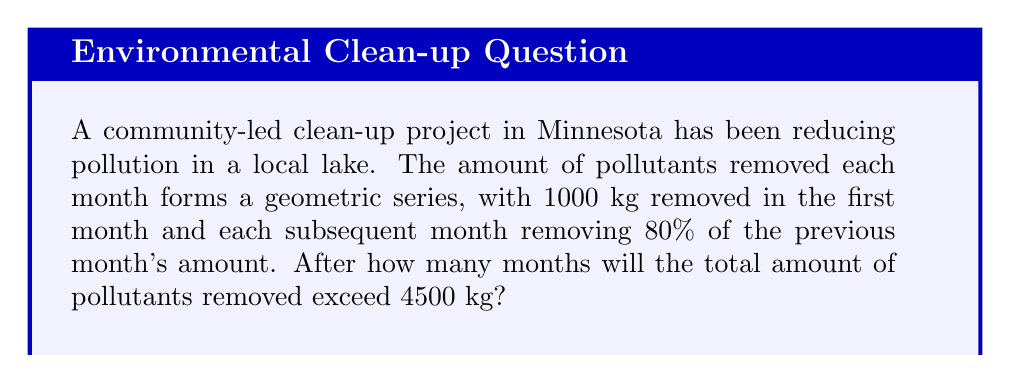Provide a solution to this math problem. Let's approach this step-by-step:

1) Let $a$ be the first term and $r$ be the common ratio of the geometric series.
   $a = 1000$ kg (first month's removal)
   $r = 0.8$ (each month removes 80% of the previous month)

2) The sum of a geometric series with $n$ terms is given by:
   $$S_n = a\frac{1-r^n}{1-r}$$

3) We want to find $n$ where $S_n > 4500$:
   $$1000\frac{1-0.8^n}{1-0.8} > 4500$$

4) Simplify:
   $$5000(1-0.8^n) > 4500$$
   $$5000 - 5000(0.8^n) > 4500$$
   $$500 > 5000(0.8^n)$$
   $$0.1 > 0.8^n$$

5) Take logarithms of both sides:
   $$\log 0.1 > n \log 0.8$$
   $$\frac{\log 0.1}{\log 0.8} < n$$

6) Calculate:
   $$\frac{\log 0.1}{\log 0.8} \approx 10.3250$$

7) Since $n$ must be a whole number of months, we round up to the next integer.
Answer: 11 months 